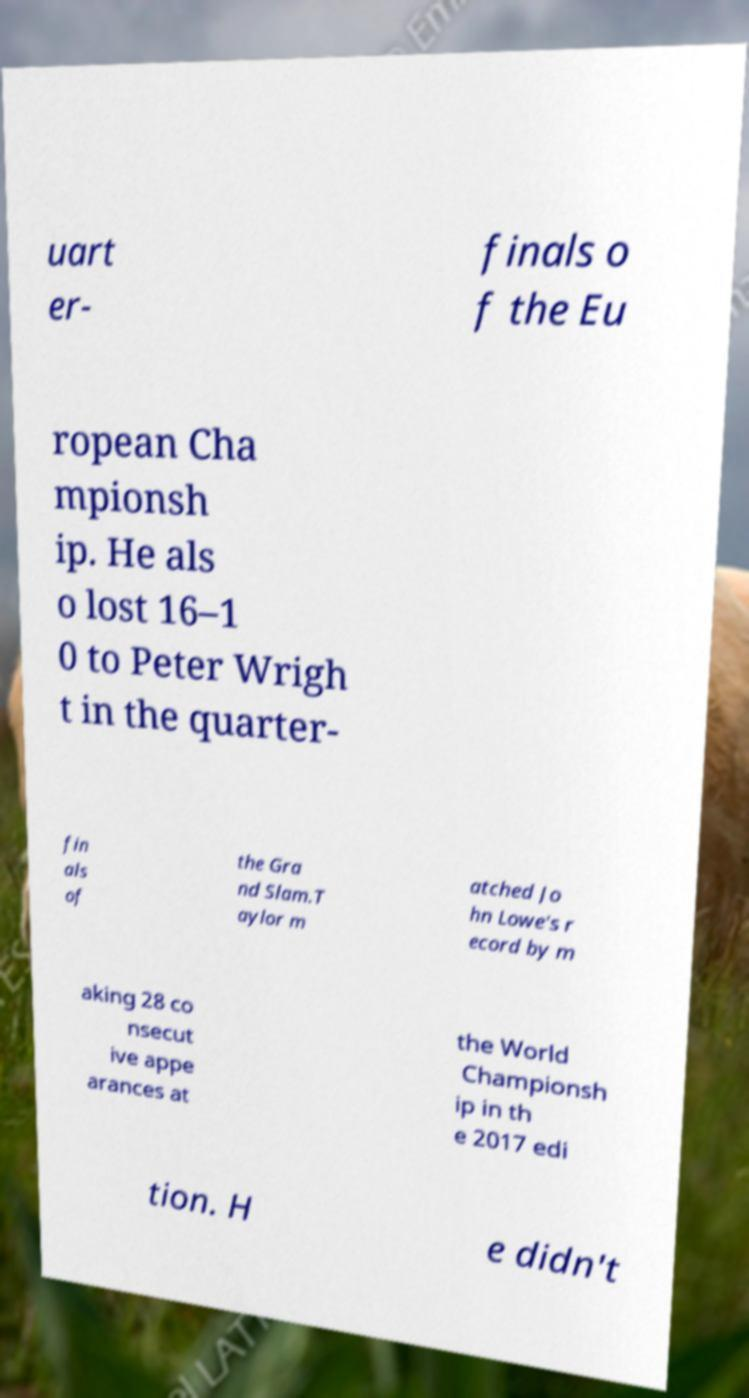Please read and relay the text visible in this image. What does it say? uart er- finals o f the Eu ropean Cha mpionsh ip. He als o lost 16–1 0 to Peter Wrigh t in the quarter- fin als of the Gra nd Slam.T aylor m atched Jo hn Lowe's r ecord by m aking 28 co nsecut ive appe arances at the World Championsh ip in th e 2017 edi tion. H e didn't 